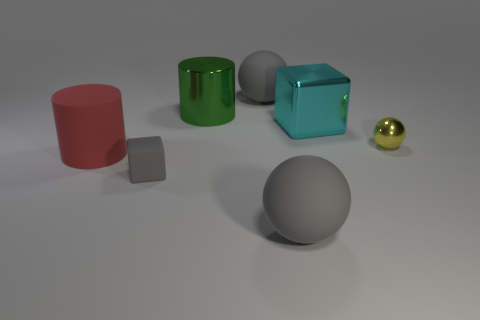Add 1 tiny red spheres. How many objects exist? 8 Subtract all spheres. How many objects are left? 4 Add 5 tiny gray cubes. How many tiny gray cubes are left? 6 Add 3 yellow objects. How many yellow objects exist? 4 Subtract 0 red blocks. How many objects are left? 7 Subtract all big blocks. Subtract all big spheres. How many objects are left? 4 